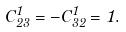Convert formula to latex. <formula><loc_0><loc_0><loc_500><loc_500>C ^ { 1 } _ { 2 3 } = - C ^ { 1 } _ { 3 2 } = 1 .</formula> 